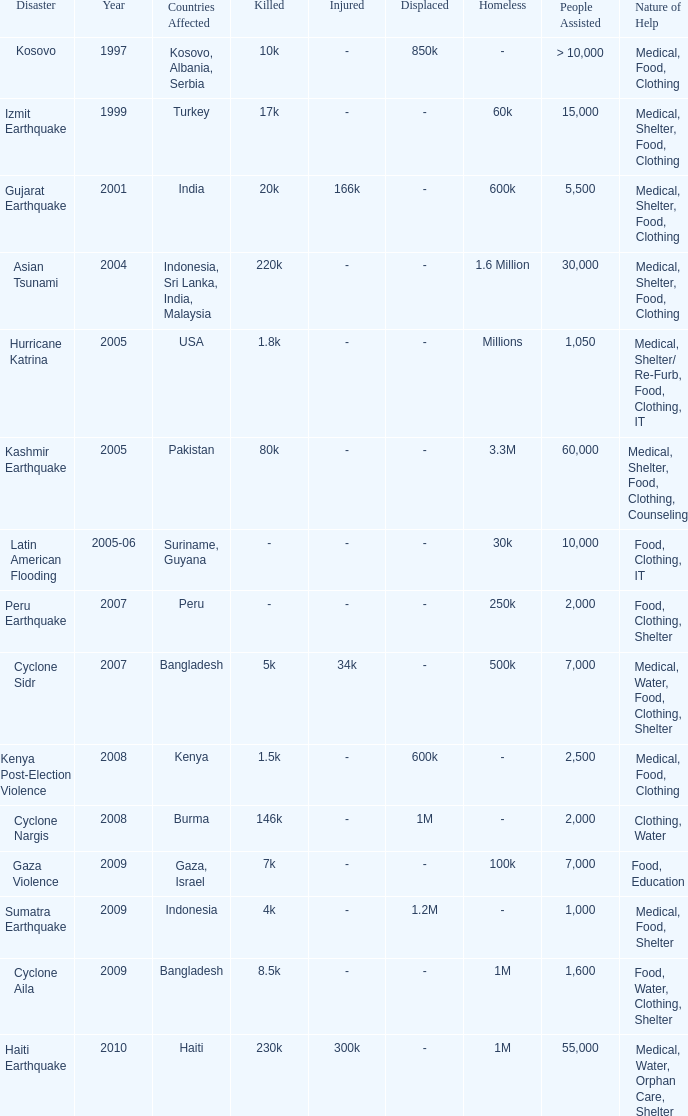In the catastrophe where 1,000 people received aid, what form did this assistance take? Medical, Food, Shelter. Would you mind parsing the complete table? {'header': ['Disaster', 'Year', 'Countries Affected', 'Killed', 'Injured', 'Displaced', 'Homeless', 'People Assisted', 'Nature of Help'], 'rows': [['Kosovo', '1997', 'Kosovo, Albania, Serbia', '10k', '-', '850k', '-', '> 10,000', 'Medical, Food, Clothing'], ['Izmit Earthquake', '1999', 'Turkey', '17k', '-', '-', '60k', '15,000', 'Medical, Shelter, Food, Clothing'], ['Gujarat Earthquake', '2001', 'India', '20k', '166k', '-', '600k', '5,500', 'Medical, Shelter, Food, Clothing'], ['Asian Tsunami', '2004', 'Indonesia, Sri Lanka, India, Malaysia', '220k', '-', '-', '1.6 Million', '30,000', 'Medical, Shelter, Food, Clothing'], ['Hurricane Katrina', '2005', 'USA', '1.8k', '-', '-', 'Millions', '1,050', 'Medical, Shelter/ Re-Furb, Food, Clothing, IT'], ['Kashmir Earthquake', '2005', 'Pakistan', '80k', '-', '-', '3.3M', '60,000', 'Medical, Shelter, Food, Clothing, Counseling'], ['Latin American Flooding', '2005-06', 'Suriname, Guyana', '-', '-', '-', '30k', '10,000', 'Food, Clothing, IT'], ['Peru Earthquake', '2007', 'Peru', '-', '-', '-', '250k', '2,000', 'Food, Clothing, Shelter'], ['Cyclone Sidr', '2007', 'Bangladesh', '5k', '34k', '-', '500k', '7,000', 'Medical, Water, Food, Clothing, Shelter'], ['Kenya Post-Election Violence', '2008', 'Kenya', '1.5k', '-', '600k', '-', '2,500', 'Medical, Food, Clothing'], ['Cyclone Nargis', '2008', 'Burma', '146k', '-', '1M', '-', '2,000', 'Clothing, Water'], ['Gaza Violence', '2009', 'Gaza, Israel', '7k', '-', '-', '100k', '7,000', 'Food, Education'], ['Sumatra Earthquake', '2009', 'Indonesia', '4k', '-', '1.2M', '-', '1,000', 'Medical, Food, Shelter'], ['Cyclone Aila', '2009', 'Bangladesh', '8.5k', '-', '-', '1M', '1,600', 'Food, Water, Clothing, Shelter'], ['Haiti Earthquake', '2010', 'Haiti', '230k', '300k', '-', '1M', '55,000', 'Medical, Water, Orphan Care, Shelter']]} 